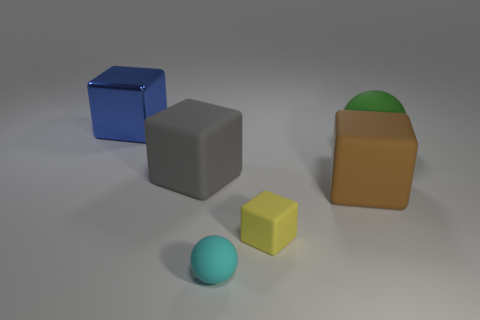How many things are left of the big block that is right of the rubber thing that is left of the tiny matte ball?
Provide a short and direct response. 4. Is there any other thing that has the same color as the small rubber ball?
Offer a very short reply. No. Does the block behind the green matte object have the same size as the gray rubber thing?
Your answer should be compact. Yes. How many cyan objects are right of the sphere that is on the left side of the green sphere?
Give a very brief answer. 0. There is a big rubber object that is left of the tiny yellow object that is in front of the green rubber object; are there any large things that are in front of it?
Make the answer very short. Yes. There is a tiny cyan thing that is the same shape as the green matte object; what is its material?
Your answer should be very brief. Rubber. Is there any other thing that is the same material as the large blue block?
Offer a terse response. No. Does the small ball have the same material as the blue cube to the left of the small yellow cube?
Ensure brevity in your answer.  No. There is a tiny thing behind the rubber sphere that is in front of the large gray rubber block; what shape is it?
Offer a very short reply. Cube. How many large objects are rubber things or green rubber things?
Offer a terse response. 3. 